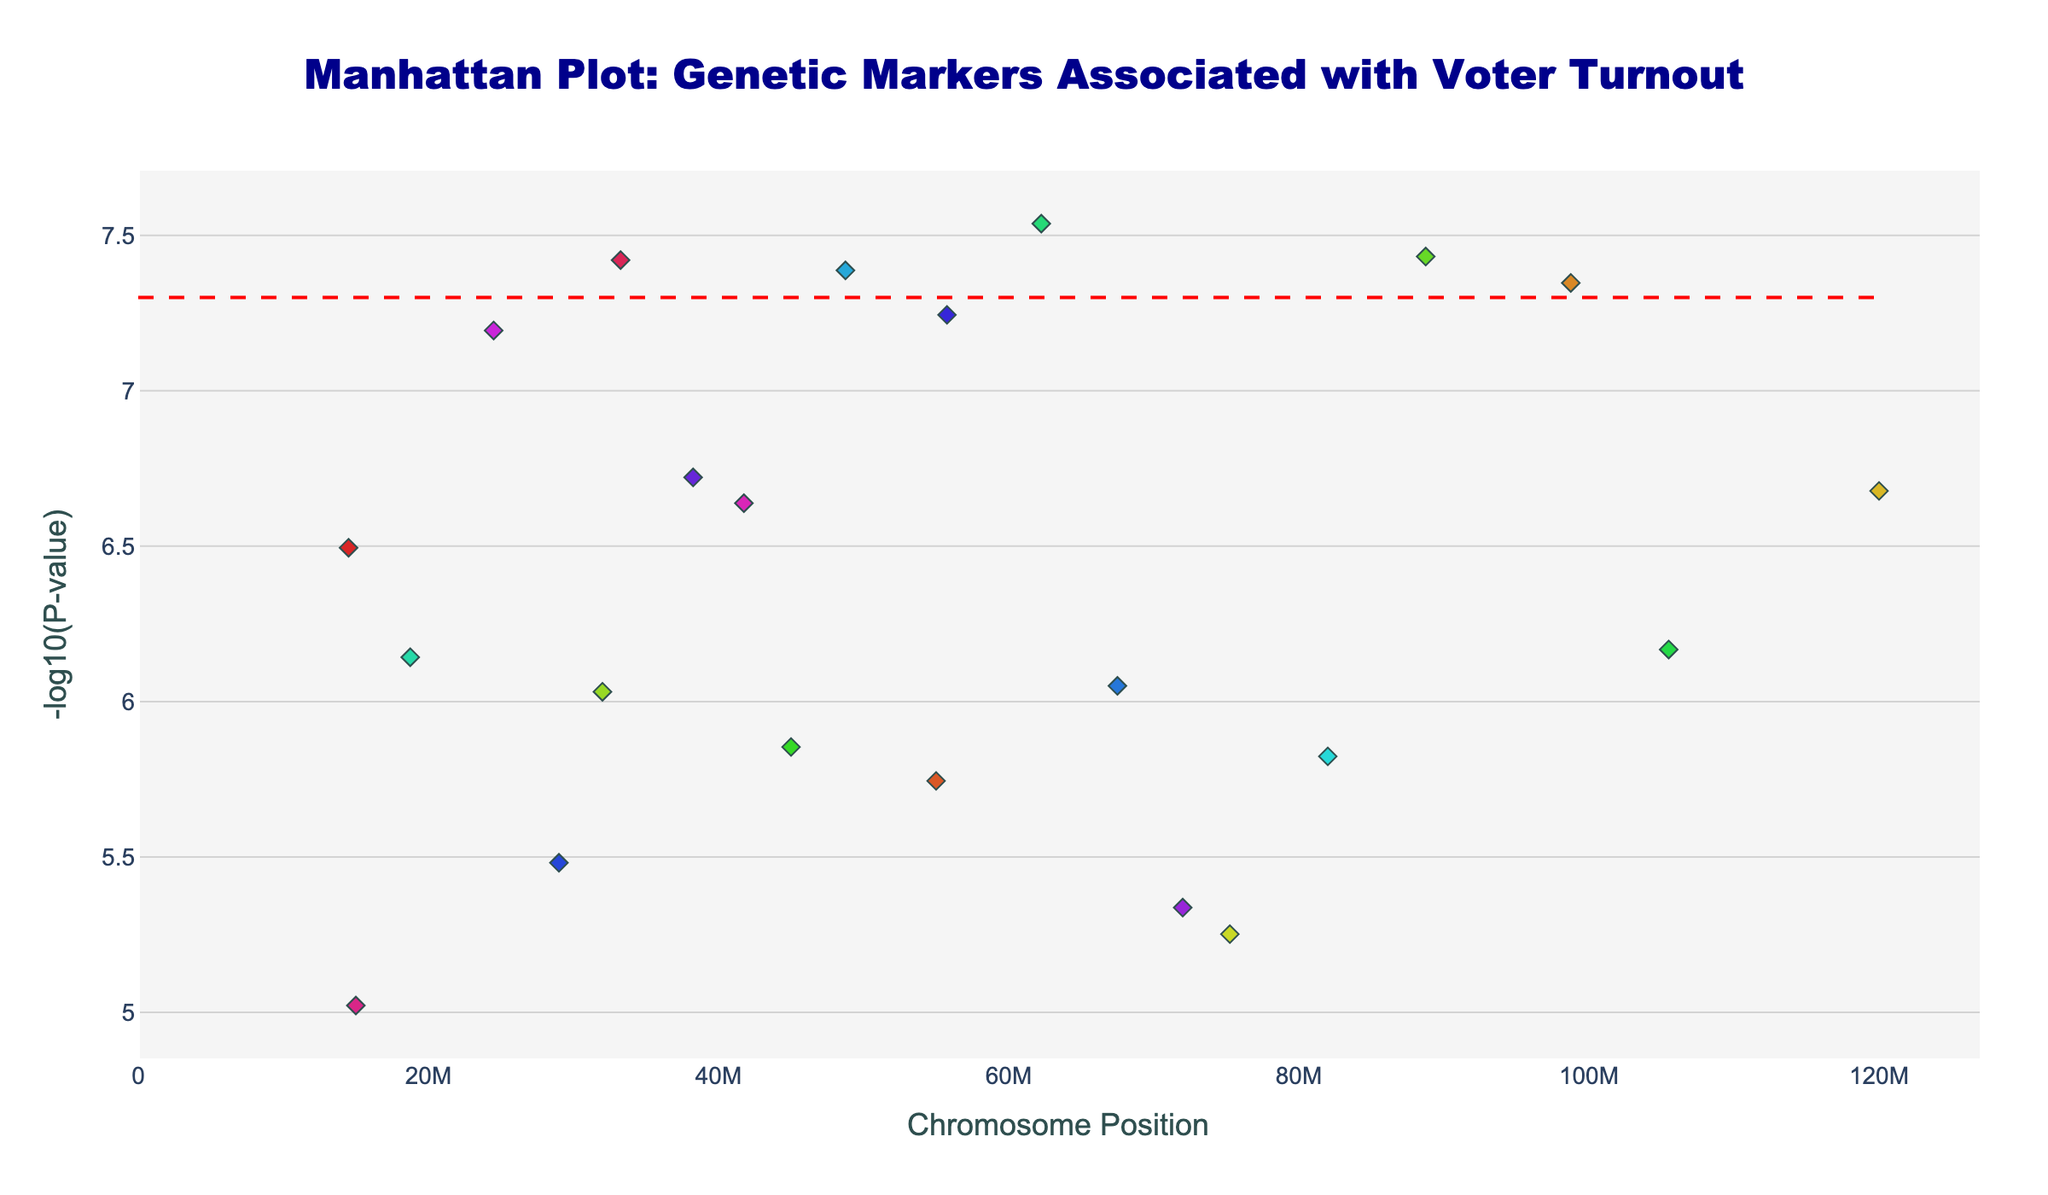What is the title of the Manhattan Plot? The title of the plot is prominently displayed at the top of the figure. It describes the overall purpose of the plot, which is to show genetic markers associated with voter turnout.
Answer: Manhattan Plot: Genetic Markers Associated with Voter Turnout What is shown on the x-axis of the plot? The x-axis represents the chromosome positions where the SNPs (Single Nucleotide Polymorphisms) are located.
Answer: Chromosome Position What is represented by the y-axis values? The y-axis values represent the negative logarithm of the P-values for each SNP, specifically -log10(P-value).
Answer: -log10(P-value) Which SNP has the smallest P-value in the data? We need to identify the highest point on the y-axis because the y-axis shows -log10(P-value). The SNP corresponding to this point is rs7654321.
Answer: rs7654321 How many chromosomes are represented in the plot? Chromosome numbers are given in the data, and each chromosome is plotted independently. Checking the chromosome field reveals 22 unique chromosomes.
Answer: 22 Which chromosome has the highest number of SNPs plotted? We need to count the number of points for each chromosome in the plot. Chromosome 10 has the highest number of SNPs with multiple points.
Answer: Chromosome 10 Which chromosome has the SNP with the greatest -log10(P-value) and what is its value? Chromosome 10 has the highest point, corresponding to the SNP rs5432109. Its -log10(P-value) is 7.54 (calculated as -log10(2.9e-8)).
Answer: Chromosome 10, 7.54 Are there any points below the red significance line? The red significance line, at 7.3, marks -log10(5e-8). To see if any points are below this level, we look along the y-axis and compare. Many SNP points, including the one at -log10(3.3e-6) and others, are below this line.
Answer: Yes Which two chromosomes have the nearest neighboring high -log10(P-value) SNPs in the plot? To identify the nearest high SNPs, we can visually compare distances along the x-axis at the higher y-values. Chromosomes 7 and 13 (points rs6543210 and rs6789012) are close together and both have high values.
Answer: Chromosomes 7 and 13 